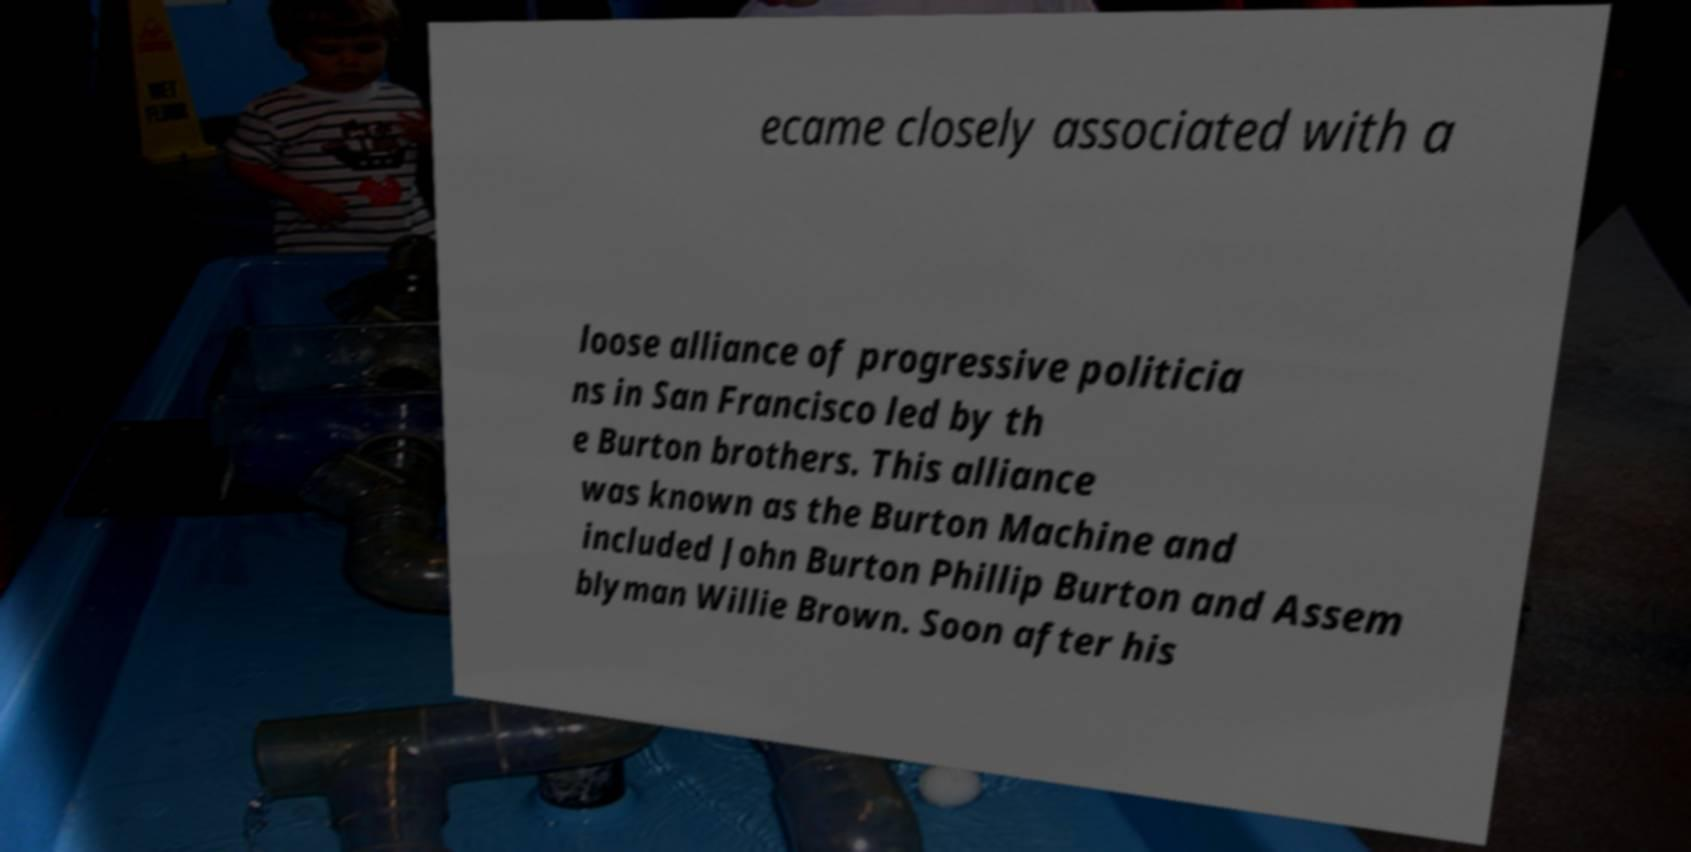There's text embedded in this image that I need extracted. Can you transcribe it verbatim? ecame closely associated with a loose alliance of progressive politicia ns in San Francisco led by th e Burton brothers. This alliance was known as the Burton Machine and included John Burton Phillip Burton and Assem blyman Willie Brown. Soon after his 